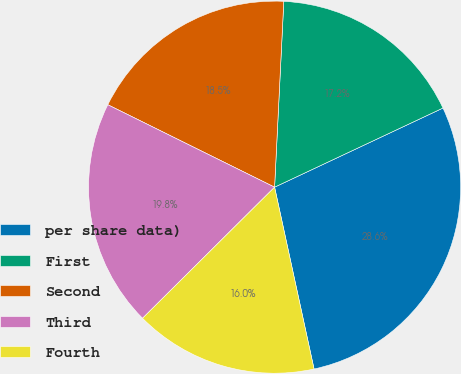Convert chart. <chart><loc_0><loc_0><loc_500><loc_500><pie_chart><fcel>per share data)<fcel>First<fcel>Second<fcel>Third<fcel>Fourth<nl><fcel>28.59%<fcel>17.22%<fcel>18.48%<fcel>19.75%<fcel>15.96%<nl></chart> 